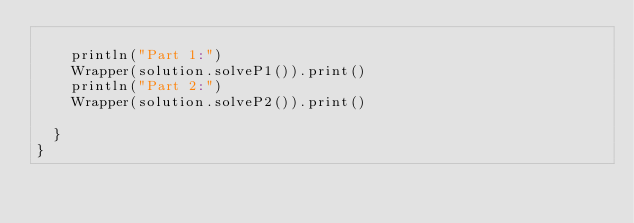Convert code to text. <code><loc_0><loc_0><loc_500><loc_500><_Scala_>
    println("Part 1:")
    Wrapper(solution.solveP1()).print()
    println("Part 2:")
    Wrapper(solution.solveP2()).print()

  }
}
</code> 